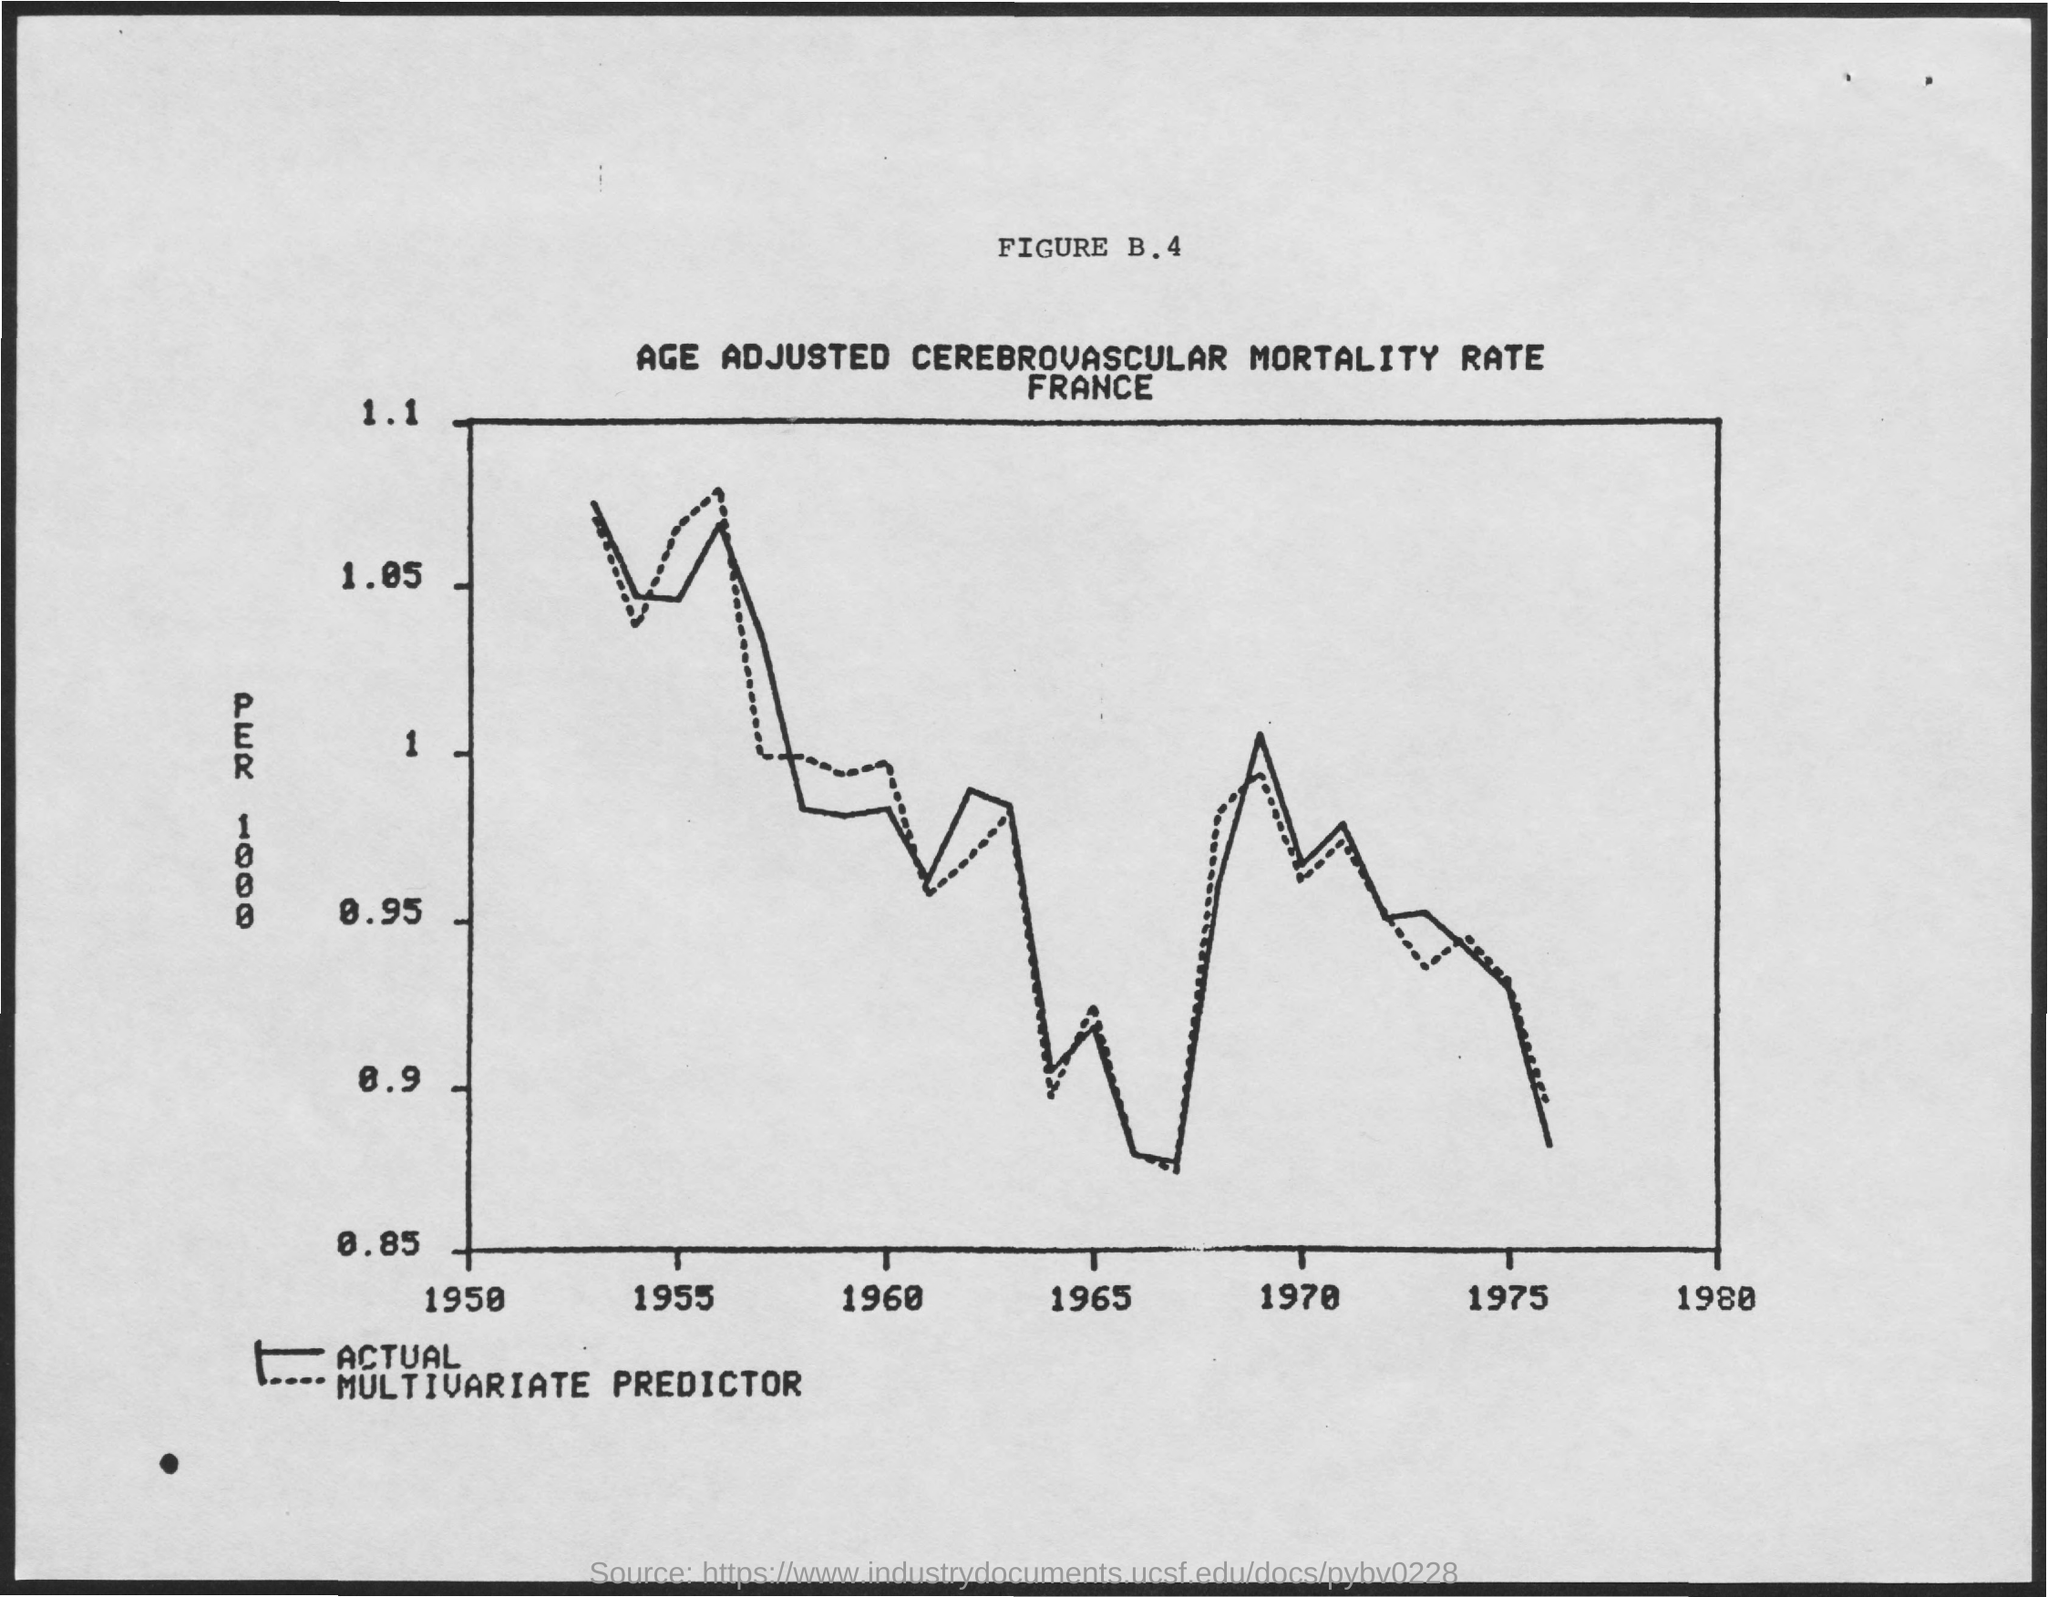Indicate a few pertinent items in this graphic. The title mentioned is the age-adjusted cerebrovascular mortality rate in France. The figure number mentioned is B.4. 